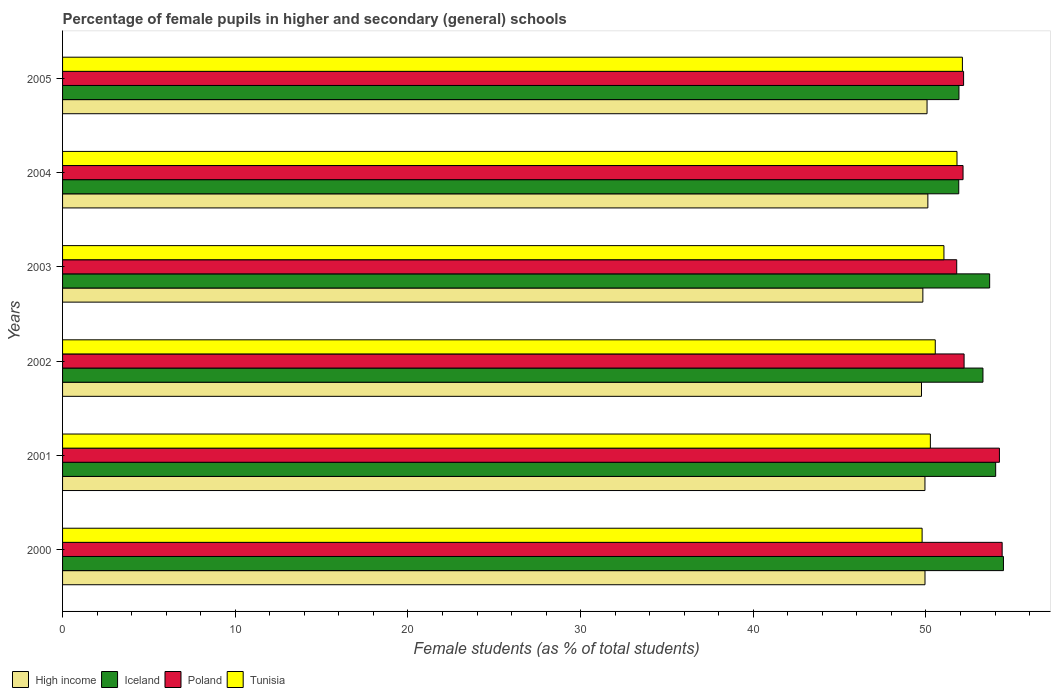How many different coloured bars are there?
Provide a succinct answer. 4. How many bars are there on the 2nd tick from the bottom?
Your answer should be very brief. 4. In how many cases, is the number of bars for a given year not equal to the number of legend labels?
Your answer should be compact. 0. What is the percentage of female pupils in higher and secondary schools in Iceland in 2005?
Your response must be concise. 51.91. Across all years, what is the maximum percentage of female pupils in higher and secondary schools in Iceland?
Keep it short and to the point. 54.49. Across all years, what is the minimum percentage of female pupils in higher and secondary schools in Iceland?
Your response must be concise. 51.9. What is the total percentage of female pupils in higher and secondary schools in High income in the graph?
Provide a succinct answer. 299.61. What is the difference between the percentage of female pupils in higher and secondary schools in Tunisia in 2001 and that in 2002?
Your answer should be compact. -0.28. What is the difference between the percentage of female pupils in higher and secondary schools in Poland in 2004 and the percentage of female pupils in higher and secondary schools in Iceland in 2003?
Keep it short and to the point. -1.54. What is the average percentage of female pupils in higher and secondary schools in Iceland per year?
Keep it short and to the point. 53.22. In the year 2005, what is the difference between the percentage of female pupils in higher and secondary schools in Iceland and percentage of female pupils in higher and secondary schools in High income?
Offer a very short reply. 1.85. What is the ratio of the percentage of female pupils in higher and secondary schools in Poland in 2002 to that in 2005?
Give a very brief answer. 1. Is the percentage of female pupils in higher and secondary schools in High income in 2004 less than that in 2005?
Give a very brief answer. No. What is the difference between the highest and the second highest percentage of female pupils in higher and secondary schools in High income?
Provide a succinct answer. 0.05. What is the difference between the highest and the lowest percentage of female pupils in higher and secondary schools in Tunisia?
Provide a short and direct response. 2.33. Is the sum of the percentage of female pupils in higher and secondary schools in Poland in 2000 and 2004 greater than the maximum percentage of female pupils in higher and secondary schools in High income across all years?
Offer a terse response. Yes. Is it the case that in every year, the sum of the percentage of female pupils in higher and secondary schools in Tunisia and percentage of female pupils in higher and secondary schools in Poland is greater than the sum of percentage of female pupils in higher and secondary schools in Iceland and percentage of female pupils in higher and secondary schools in High income?
Your answer should be compact. Yes. What does the 3rd bar from the top in 2000 represents?
Keep it short and to the point. Iceland. What does the 4th bar from the bottom in 2004 represents?
Make the answer very short. Tunisia. Are all the bars in the graph horizontal?
Your answer should be compact. Yes. What is the difference between two consecutive major ticks on the X-axis?
Give a very brief answer. 10. Are the values on the major ticks of X-axis written in scientific E-notation?
Provide a succinct answer. No. Does the graph contain grids?
Give a very brief answer. No. How many legend labels are there?
Provide a short and direct response. 4. How are the legend labels stacked?
Offer a very short reply. Horizontal. What is the title of the graph?
Make the answer very short. Percentage of female pupils in higher and secondary (general) schools. Does "Bangladesh" appear as one of the legend labels in the graph?
Ensure brevity in your answer.  No. What is the label or title of the X-axis?
Provide a short and direct response. Female students (as % of total students). What is the Female students (as % of total students) in High income in 2000?
Give a very brief answer. 49.94. What is the Female students (as % of total students) in Iceland in 2000?
Provide a short and direct response. 54.49. What is the Female students (as % of total students) of Poland in 2000?
Your answer should be very brief. 54.41. What is the Female students (as % of total students) of Tunisia in 2000?
Provide a short and direct response. 49.78. What is the Female students (as % of total students) in High income in 2001?
Offer a very short reply. 49.94. What is the Female students (as % of total students) in Iceland in 2001?
Provide a short and direct response. 54.04. What is the Female students (as % of total students) in Poland in 2001?
Give a very brief answer. 54.25. What is the Female students (as % of total students) in Tunisia in 2001?
Your answer should be compact. 50.25. What is the Female students (as % of total students) in High income in 2002?
Offer a terse response. 49.74. What is the Female students (as % of total students) of Iceland in 2002?
Your response must be concise. 53.3. What is the Female students (as % of total students) of Poland in 2002?
Your answer should be very brief. 52.21. What is the Female students (as % of total students) of Tunisia in 2002?
Your response must be concise. 50.54. What is the Female students (as % of total students) of High income in 2003?
Offer a very short reply. 49.82. What is the Female students (as % of total students) of Iceland in 2003?
Your response must be concise. 53.69. What is the Female students (as % of total students) in Poland in 2003?
Your answer should be very brief. 51.78. What is the Female students (as % of total students) in Tunisia in 2003?
Keep it short and to the point. 51.04. What is the Female students (as % of total students) of High income in 2004?
Provide a succinct answer. 50.11. What is the Female students (as % of total students) in Iceland in 2004?
Provide a succinct answer. 51.9. What is the Female students (as % of total students) of Poland in 2004?
Offer a terse response. 52.15. What is the Female students (as % of total students) of Tunisia in 2004?
Your answer should be compact. 51.8. What is the Female students (as % of total students) of High income in 2005?
Give a very brief answer. 50.06. What is the Female students (as % of total students) of Iceland in 2005?
Provide a short and direct response. 51.91. What is the Female students (as % of total students) of Poland in 2005?
Offer a very short reply. 52.18. What is the Female students (as % of total students) in Tunisia in 2005?
Offer a terse response. 52.11. Across all years, what is the maximum Female students (as % of total students) of High income?
Give a very brief answer. 50.11. Across all years, what is the maximum Female students (as % of total students) in Iceland?
Give a very brief answer. 54.49. Across all years, what is the maximum Female students (as % of total students) in Poland?
Your answer should be compact. 54.41. Across all years, what is the maximum Female students (as % of total students) in Tunisia?
Give a very brief answer. 52.11. Across all years, what is the minimum Female students (as % of total students) in High income?
Offer a terse response. 49.74. Across all years, what is the minimum Female students (as % of total students) in Iceland?
Offer a very short reply. 51.9. Across all years, what is the minimum Female students (as % of total students) in Poland?
Provide a short and direct response. 51.78. Across all years, what is the minimum Female students (as % of total students) of Tunisia?
Your response must be concise. 49.78. What is the total Female students (as % of total students) in High income in the graph?
Ensure brevity in your answer.  299.61. What is the total Female students (as % of total students) in Iceland in the graph?
Your answer should be very brief. 319.32. What is the total Female students (as % of total students) of Poland in the graph?
Provide a short and direct response. 316.98. What is the total Female students (as % of total students) in Tunisia in the graph?
Give a very brief answer. 305.51. What is the difference between the Female students (as % of total students) of High income in 2000 and that in 2001?
Offer a terse response. 0. What is the difference between the Female students (as % of total students) in Iceland in 2000 and that in 2001?
Offer a terse response. 0.45. What is the difference between the Female students (as % of total students) of Poland in 2000 and that in 2001?
Your response must be concise. 0.16. What is the difference between the Female students (as % of total students) in Tunisia in 2000 and that in 2001?
Provide a succinct answer. -0.48. What is the difference between the Female students (as % of total students) in High income in 2000 and that in 2002?
Provide a succinct answer. 0.2. What is the difference between the Female students (as % of total students) of Iceland in 2000 and that in 2002?
Keep it short and to the point. 1.19. What is the difference between the Female students (as % of total students) of Poland in 2000 and that in 2002?
Give a very brief answer. 2.2. What is the difference between the Female students (as % of total students) in Tunisia in 2000 and that in 2002?
Your response must be concise. -0.76. What is the difference between the Female students (as % of total students) in High income in 2000 and that in 2003?
Your answer should be compact. 0.12. What is the difference between the Female students (as % of total students) of Iceland in 2000 and that in 2003?
Provide a succinct answer. 0.8. What is the difference between the Female students (as % of total students) in Poland in 2000 and that in 2003?
Keep it short and to the point. 2.63. What is the difference between the Female students (as % of total students) of Tunisia in 2000 and that in 2003?
Your response must be concise. -1.26. What is the difference between the Female students (as % of total students) in High income in 2000 and that in 2004?
Offer a terse response. -0.17. What is the difference between the Female students (as % of total students) in Iceland in 2000 and that in 2004?
Your response must be concise. 2.59. What is the difference between the Female students (as % of total students) of Poland in 2000 and that in 2004?
Ensure brevity in your answer.  2.27. What is the difference between the Female students (as % of total students) in Tunisia in 2000 and that in 2004?
Your answer should be compact. -2.02. What is the difference between the Female students (as % of total students) in High income in 2000 and that in 2005?
Provide a short and direct response. -0.12. What is the difference between the Female students (as % of total students) of Iceland in 2000 and that in 2005?
Provide a succinct answer. 2.58. What is the difference between the Female students (as % of total students) of Poland in 2000 and that in 2005?
Give a very brief answer. 2.23. What is the difference between the Female students (as % of total students) of Tunisia in 2000 and that in 2005?
Your answer should be very brief. -2.33. What is the difference between the Female students (as % of total students) in High income in 2001 and that in 2002?
Your response must be concise. 0.2. What is the difference between the Female students (as % of total students) of Iceland in 2001 and that in 2002?
Keep it short and to the point. 0.74. What is the difference between the Female students (as % of total students) of Poland in 2001 and that in 2002?
Provide a succinct answer. 2.05. What is the difference between the Female students (as % of total students) in Tunisia in 2001 and that in 2002?
Offer a terse response. -0.28. What is the difference between the Female students (as % of total students) of High income in 2001 and that in 2003?
Your answer should be very brief. 0.12. What is the difference between the Female students (as % of total students) in Iceland in 2001 and that in 2003?
Provide a succinct answer. 0.35. What is the difference between the Female students (as % of total students) in Poland in 2001 and that in 2003?
Offer a very short reply. 2.47. What is the difference between the Female students (as % of total students) in Tunisia in 2001 and that in 2003?
Offer a very short reply. -0.79. What is the difference between the Female students (as % of total students) in High income in 2001 and that in 2004?
Give a very brief answer. -0.17. What is the difference between the Female students (as % of total students) in Iceland in 2001 and that in 2004?
Ensure brevity in your answer.  2.14. What is the difference between the Female students (as % of total students) of Poland in 2001 and that in 2004?
Provide a short and direct response. 2.11. What is the difference between the Female students (as % of total students) in Tunisia in 2001 and that in 2004?
Your response must be concise. -1.54. What is the difference between the Female students (as % of total students) of High income in 2001 and that in 2005?
Offer a very short reply. -0.12. What is the difference between the Female students (as % of total students) in Iceland in 2001 and that in 2005?
Provide a short and direct response. 2.13. What is the difference between the Female students (as % of total students) of Poland in 2001 and that in 2005?
Make the answer very short. 2.08. What is the difference between the Female students (as % of total students) in Tunisia in 2001 and that in 2005?
Provide a succinct answer. -1.86. What is the difference between the Female students (as % of total students) of High income in 2002 and that in 2003?
Your answer should be very brief. -0.08. What is the difference between the Female students (as % of total students) of Iceland in 2002 and that in 2003?
Your response must be concise. -0.39. What is the difference between the Female students (as % of total students) of Poland in 2002 and that in 2003?
Offer a very short reply. 0.43. What is the difference between the Female students (as % of total students) in Tunisia in 2002 and that in 2003?
Your answer should be very brief. -0.5. What is the difference between the Female students (as % of total students) of High income in 2002 and that in 2004?
Your response must be concise. -0.37. What is the difference between the Female students (as % of total students) of Iceland in 2002 and that in 2004?
Your answer should be compact. 1.4. What is the difference between the Female students (as % of total students) of Poland in 2002 and that in 2004?
Ensure brevity in your answer.  0.06. What is the difference between the Female students (as % of total students) in Tunisia in 2002 and that in 2004?
Offer a very short reply. -1.26. What is the difference between the Female students (as % of total students) in High income in 2002 and that in 2005?
Your answer should be very brief. -0.32. What is the difference between the Female students (as % of total students) in Iceland in 2002 and that in 2005?
Your answer should be compact. 1.39. What is the difference between the Female students (as % of total students) in Poland in 2002 and that in 2005?
Your response must be concise. 0.03. What is the difference between the Female students (as % of total students) in Tunisia in 2002 and that in 2005?
Offer a terse response. -1.57. What is the difference between the Female students (as % of total students) in High income in 2003 and that in 2004?
Provide a succinct answer. -0.29. What is the difference between the Female students (as % of total students) in Iceland in 2003 and that in 2004?
Your answer should be compact. 1.79. What is the difference between the Female students (as % of total students) of Poland in 2003 and that in 2004?
Ensure brevity in your answer.  -0.37. What is the difference between the Female students (as % of total students) in Tunisia in 2003 and that in 2004?
Offer a very short reply. -0.76. What is the difference between the Female students (as % of total students) in High income in 2003 and that in 2005?
Offer a terse response. -0.24. What is the difference between the Female students (as % of total students) in Iceland in 2003 and that in 2005?
Give a very brief answer. 1.78. What is the difference between the Female students (as % of total students) in Poland in 2003 and that in 2005?
Your response must be concise. -0.4. What is the difference between the Female students (as % of total students) in Tunisia in 2003 and that in 2005?
Ensure brevity in your answer.  -1.07. What is the difference between the Female students (as % of total students) of High income in 2004 and that in 2005?
Your answer should be very brief. 0.05. What is the difference between the Female students (as % of total students) of Iceland in 2004 and that in 2005?
Make the answer very short. -0.01. What is the difference between the Female students (as % of total students) in Poland in 2004 and that in 2005?
Offer a terse response. -0.03. What is the difference between the Female students (as % of total students) in Tunisia in 2004 and that in 2005?
Keep it short and to the point. -0.31. What is the difference between the Female students (as % of total students) of High income in 2000 and the Female students (as % of total students) of Iceland in 2001?
Provide a succinct answer. -4.09. What is the difference between the Female students (as % of total students) in High income in 2000 and the Female students (as % of total students) in Poland in 2001?
Provide a short and direct response. -4.31. What is the difference between the Female students (as % of total students) of High income in 2000 and the Female students (as % of total students) of Tunisia in 2001?
Offer a very short reply. -0.31. What is the difference between the Female students (as % of total students) of Iceland in 2000 and the Female students (as % of total students) of Poland in 2001?
Ensure brevity in your answer.  0.23. What is the difference between the Female students (as % of total students) in Iceland in 2000 and the Female students (as % of total students) in Tunisia in 2001?
Ensure brevity in your answer.  4.23. What is the difference between the Female students (as % of total students) of Poland in 2000 and the Female students (as % of total students) of Tunisia in 2001?
Keep it short and to the point. 4.16. What is the difference between the Female students (as % of total students) in High income in 2000 and the Female students (as % of total students) in Iceland in 2002?
Your answer should be compact. -3.36. What is the difference between the Female students (as % of total students) in High income in 2000 and the Female students (as % of total students) in Poland in 2002?
Your response must be concise. -2.26. What is the difference between the Female students (as % of total students) of High income in 2000 and the Female students (as % of total students) of Tunisia in 2002?
Your response must be concise. -0.59. What is the difference between the Female students (as % of total students) of Iceland in 2000 and the Female students (as % of total students) of Poland in 2002?
Offer a terse response. 2.28. What is the difference between the Female students (as % of total students) in Iceland in 2000 and the Female students (as % of total students) in Tunisia in 2002?
Give a very brief answer. 3.95. What is the difference between the Female students (as % of total students) of Poland in 2000 and the Female students (as % of total students) of Tunisia in 2002?
Make the answer very short. 3.87. What is the difference between the Female students (as % of total students) in High income in 2000 and the Female students (as % of total students) in Iceland in 2003?
Keep it short and to the point. -3.74. What is the difference between the Female students (as % of total students) in High income in 2000 and the Female students (as % of total students) in Poland in 2003?
Keep it short and to the point. -1.84. What is the difference between the Female students (as % of total students) of High income in 2000 and the Female students (as % of total students) of Tunisia in 2003?
Keep it short and to the point. -1.1. What is the difference between the Female students (as % of total students) of Iceland in 2000 and the Female students (as % of total students) of Poland in 2003?
Ensure brevity in your answer.  2.71. What is the difference between the Female students (as % of total students) in Iceland in 2000 and the Female students (as % of total students) in Tunisia in 2003?
Give a very brief answer. 3.45. What is the difference between the Female students (as % of total students) in Poland in 2000 and the Female students (as % of total students) in Tunisia in 2003?
Your answer should be compact. 3.37. What is the difference between the Female students (as % of total students) in High income in 2000 and the Female students (as % of total students) in Iceland in 2004?
Your response must be concise. -1.95. What is the difference between the Female students (as % of total students) of High income in 2000 and the Female students (as % of total students) of Poland in 2004?
Provide a short and direct response. -2.2. What is the difference between the Female students (as % of total students) of High income in 2000 and the Female students (as % of total students) of Tunisia in 2004?
Your response must be concise. -1.85. What is the difference between the Female students (as % of total students) of Iceland in 2000 and the Female students (as % of total students) of Poland in 2004?
Offer a very short reply. 2.34. What is the difference between the Female students (as % of total students) of Iceland in 2000 and the Female students (as % of total students) of Tunisia in 2004?
Give a very brief answer. 2.69. What is the difference between the Female students (as % of total students) of Poland in 2000 and the Female students (as % of total students) of Tunisia in 2004?
Your response must be concise. 2.62. What is the difference between the Female students (as % of total students) of High income in 2000 and the Female students (as % of total students) of Iceland in 2005?
Provide a succinct answer. -1.97. What is the difference between the Female students (as % of total students) in High income in 2000 and the Female students (as % of total students) in Poland in 2005?
Provide a succinct answer. -2.23. What is the difference between the Female students (as % of total students) in High income in 2000 and the Female students (as % of total students) in Tunisia in 2005?
Provide a succinct answer. -2.17. What is the difference between the Female students (as % of total students) in Iceland in 2000 and the Female students (as % of total students) in Poland in 2005?
Keep it short and to the point. 2.31. What is the difference between the Female students (as % of total students) of Iceland in 2000 and the Female students (as % of total students) of Tunisia in 2005?
Give a very brief answer. 2.38. What is the difference between the Female students (as % of total students) in Poland in 2000 and the Female students (as % of total students) in Tunisia in 2005?
Your answer should be compact. 2.3. What is the difference between the Female students (as % of total students) of High income in 2001 and the Female students (as % of total students) of Iceland in 2002?
Keep it short and to the point. -3.36. What is the difference between the Female students (as % of total students) in High income in 2001 and the Female students (as % of total students) in Poland in 2002?
Make the answer very short. -2.27. What is the difference between the Female students (as % of total students) in High income in 2001 and the Female students (as % of total students) in Tunisia in 2002?
Give a very brief answer. -0.6. What is the difference between the Female students (as % of total students) in Iceland in 2001 and the Female students (as % of total students) in Poland in 2002?
Keep it short and to the point. 1.83. What is the difference between the Female students (as % of total students) in Iceland in 2001 and the Female students (as % of total students) in Tunisia in 2002?
Make the answer very short. 3.5. What is the difference between the Female students (as % of total students) of Poland in 2001 and the Female students (as % of total students) of Tunisia in 2002?
Offer a terse response. 3.72. What is the difference between the Female students (as % of total students) of High income in 2001 and the Female students (as % of total students) of Iceland in 2003?
Ensure brevity in your answer.  -3.75. What is the difference between the Female students (as % of total students) in High income in 2001 and the Female students (as % of total students) in Poland in 2003?
Keep it short and to the point. -1.84. What is the difference between the Female students (as % of total students) of High income in 2001 and the Female students (as % of total students) of Tunisia in 2003?
Offer a terse response. -1.1. What is the difference between the Female students (as % of total students) of Iceland in 2001 and the Female students (as % of total students) of Poland in 2003?
Give a very brief answer. 2.26. What is the difference between the Female students (as % of total students) in Iceland in 2001 and the Female students (as % of total students) in Tunisia in 2003?
Provide a succinct answer. 3. What is the difference between the Female students (as % of total students) in Poland in 2001 and the Female students (as % of total students) in Tunisia in 2003?
Offer a terse response. 3.21. What is the difference between the Female students (as % of total students) in High income in 2001 and the Female students (as % of total students) in Iceland in 2004?
Your answer should be compact. -1.96. What is the difference between the Female students (as % of total students) of High income in 2001 and the Female students (as % of total students) of Poland in 2004?
Ensure brevity in your answer.  -2.21. What is the difference between the Female students (as % of total students) in High income in 2001 and the Female students (as % of total students) in Tunisia in 2004?
Ensure brevity in your answer.  -1.86. What is the difference between the Female students (as % of total students) in Iceland in 2001 and the Female students (as % of total students) in Poland in 2004?
Your answer should be very brief. 1.89. What is the difference between the Female students (as % of total students) of Iceland in 2001 and the Female students (as % of total students) of Tunisia in 2004?
Make the answer very short. 2.24. What is the difference between the Female students (as % of total students) in Poland in 2001 and the Female students (as % of total students) in Tunisia in 2004?
Give a very brief answer. 2.46. What is the difference between the Female students (as % of total students) of High income in 2001 and the Female students (as % of total students) of Iceland in 2005?
Your answer should be compact. -1.97. What is the difference between the Female students (as % of total students) in High income in 2001 and the Female students (as % of total students) in Poland in 2005?
Offer a terse response. -2.24. What is the difference between the Female students (as % of total students) in High income in 2001 and the Female students (as % of total students) in Tunisia in 2005?
Give a very brief answer. -2.17. What is the difference between the Female students (as % of total students) in Iceland in 2001 and the Female students (as % of total students) in Poland in 2005?
Your answer should be compact. 1.86. What is the difference between the Female students (as % of total students) of Iceland in 2001 and the Female students (as % of total students) of Tunisia in 2005?
Provide a succinct answer. 1.93. What is the difference between the Female students (as % of total students) in Poland in 2001 and the Female students (as % of total students) in Tunisia in 2005?
Give a very brief answer. 2.14. What is the difference between the Female students (as % of total students) in High income in 2002 and the Female students (as % of total students) in Iceland in 2003?
Your answer should be compact. -3.95. What is the difference between the Female students (as % of total students) in High income in 2002 and the Female students (as % of total students) in Poland in 2003?
Provide a short and direct response. -2.04. What is the difference between the Female students (as % of total students) of High income in 2002 and the Female students (as % of total students) of Tunisia in 2003?
Your answer should be compact. -1.3. What is the difference between the Female students (as % of total students) of Iceland in 2002 and the Female students (as % of total students) of Poland in 2003?
Make the answer very short. 1.52. What is the difference between the Female students (as % of total students) in Iceland in 2002 and the Female students (as % of total students) in Tunisia in 2003?
Offer a very short reply. 2.26. What is the difference between the Female students (as % of total students) in Poland in 2002 and the Female students (as % of total students) in Tunisia in 2003?
Your response must be concise. 1.17. What is the difference between the Female students (as % of total students) in High income in 2002 and the Female students (as % of total students) in Iceland in 2004?
Give a very brief answer. -2.16. What is the difference between the Female students (as % of total students) in High income in 2002 and the Female students (as % of total students) in Poland in 2004?
Your answer should be very brief. -2.41. What is the difference between the Female students (as % of total students) of High income in 2002 and the Female students (as % of total students) of Tunisia in 2004?
Offer a very short reply. -2.06. What is the difference between the Female students (as % of total students) of Iceland in 2002 and the Female students (as % of total students) of Poland in 2004?
Keep it short and to the point. 1.15. What is the difference between the Female students (as % of total students) of Iceland in 2002 and the Female students (as % of total students) of Tunisia in 2004?
Make the answer very short. 1.5. What is the difference between the Female students (as % of total students) of Poland in 2002 and the Female students (as % of total students) of Tunisia in 2004?
Ensure brevity in your answer.  0.41. What is the difference between the Female students (as % of total students) in High income in 2002 and the Female students (as % of total students) in Iceland in 2005?
Your answer should be very brief. -2.17. What is the difference between the Female students (as % of total students) of High income in 2002 and the Female students (as % of total students) of Poland in 2005?
Ensure brevity in your answer.  -2.44. What is the difference between the Female students (as % of total students) of High income in 2002 and the Female students (as % of total students) of Tunisia in 2005?
Provide a short and direct response. -2.37. What is the difference between the Female students (as % of total students) in Iceland in 2002 and the Female students (as % of total students) in Poland in 2005?
Make the answer very short. 1.12. What is the difference between the Female students (as % of total students) of Iceland in 2002 and the Female students (as % of total students) of Tunisia in 2005?
Provide a succinct answer. 1.19. What is the difference between the Female students (as % of total students) of Poland in 2002 and the Female students (as % of total students) of Tunisia in 2005?
Provide a succinct answer. 0.1. What is the difference between the Female students (as % of total students) in High income in 2003 and the Female students (as % of total students) in Iceland in 2004?
Your answer should be compact. -2.08. What is the difference between the Female students (as % of total students) of High income in 2003 and the Female students (as % of total students) of Poland in 2004?
Keep it short and to the point. -2.33. What is the difference between the Female students (as % of total students) of High income in 2003 and the Female students (as % of total students) of Tunisia in 2004?
Offer a terse response. -1.98. What is the difference between the Female students (as % of total students) of Iceland in 2003 and the Female students (as % of total students) of Poland in 2004?
Your answer should be compact. 1.54. What is the difference between the Female students (as % of total students) of Iceland in 2003 and the Female students (as % of total students) of Tunisia in 2004?
Your answer should be compact. 1.89. What is the difference between the Female students (as % of total students) of Poland in 2003 and the Female students (as % of total students) of Tunisia in 2004?
Keep it short and to the point. -0.02. What is the difference between the Female students (as % of total students) in High income in 2003 and the Female students (as % of total students) in Iceland in 2005?
Offer a terse response. -2.09. What is the difference between the Female students (as % of total students) of High income in 2003 and the Female students (as % of total students) of Poland in 2005?
Offer a very short reply. -2.36. What is the difference between the Female students (as % of total students) of High income in 2003 and the Female students (as % of total students) of Tunisia in 2005?
Give a very brief answer. -2.29. What is the difference between the Female students (as % of total students) in Iceland in 2003 and the Female students (as % of total students) in Poland in 2005?
Ensure brevity in your answer.  1.51. What is the difference between the Female students (as % of total students) of Iceland in 2003 and the Female students (as % of total students) of Tunisia in 2005?
Keep it short and to the point. 1.58. What is the difference between the Female students (as % of total students) of Poland in 2003 and the Female students (as % of total students) of Tunisia in 2005?
Ensure brevity in your answer.  -0.33. What is the difference between the Female students (as % of total students) in High income in 2004 and the Female students (as % of total students) in Iceland in 2005?
Provide a succinct answer. -1.8. What is the difference between the Female students (as % of total students) in High income in 2004 and the Female students (as % of total students) in Poland in 2005?
Make the answer very short. -2.07. What is the difference between the Female students (as % of total students) of High income in 2004 and the Female students (as % of total students) of Tunisia in 2005?
Ensure brevity in your answer.  -2. What is the difference between the Female students (as % of total students) in Iceland in 2004 and the Female students (as % of total students) in Poland in 2005?
Keep it short and to the point. -0.28. What is the difference between the Female students (as % of total students) in Iceland in 2004 and the Female students (as % of total students) in Tunisia in 2005?
Your answer should be very brief. -0.21. What is the difference between the Female students (as % of total students) in Poland in 2004 and the Female students (as % of total students) in Tunisia in 2005?
Your response must be concise. 0.04. What is the average Female students (as % of total students) of High income per year?
Give a very brief answer. 49.94. What is the average Female students (as % of total students) in Iceland per year?
Ensure brevity in your answer.  53.22. What is the average Female students (as % of total students) in Poland per year?
Provide a succinct answer. 52.83. What is the average Female students (as % of total students) in Tunisia per year?
Provide a short and direct response. 50.92. In the year 2000, what is the difference between the Female students (as % of total students) of High income and Female students (as % of total students) of Iceland?
Provide a succinct answer. -4.54. In the year 2000, what is the difference between the Female students (as % of total students) in High income and Female students (as % of total students) in Poland?
Make the answer very short. -4.47. In the year 2000, what is the difference between the Female students (as % of total students) of High income and Female students (as % of total students) of Tunisia?
Provide a succinct answer. 0.17. In the year 2000, what is the difference between the Female students (as % of total students) of Iceland and Female students (as % of total students) of Poland?
Your answer should be very brief. 0.07. In the year 2000, what is the difference between the Female students (as % of total students) in Iceland and Female students (as % of total students) in Tunisia?
Give a very brief answer. 4.71. In the year 2000, what is the difference between the Female students (as % of total students) in Poland and Female students (as % of total students) in Tunisia?
Offer a very short reply. 4.64. In the year 2001, what is the difference between the Female students (as % of total students) in High income and Female students (as % of total students) in Iceland?
Offer a very short reply. -4.1. In the year 2001, what is the difference between the Female students (as % of total students) in High income and Female students (as % of total students) in Poland?
Give a very brief answer. -4.31. In the year 2001, what is the difference between the Female students (as % of total students) in High income and Female students (as % of total students) in Tunisia?
Your response must be concise. -0.31. In the year 2001, what is the difference between the Female students (as % of total students) in Iceland and Female students (as % of total students) in Poland?
Your answer should be compact. -0.22. In the year 2001, what is the difference between the Female students (as % of total students) in Iceland and Female students (as % of total students) in Tunisia?
Offer a terse response. 3.78. In the year 2001, what is the difference between the Female students (as % of total students) of Poland and Female students (as % of total students) of Tunisia?
Your answer should be compact. 4. In the year 2002, what is the difference between the Female students (as % of total students) of High income and Female students (as % of total students) of Iceland?
Ensure brevity in your answer.  -3.56. In the year 2002, what is the difference between the Female students (as % of total students) in High income and Female students (as % of total students) in Poland?
Provide a succinct answer. -2.47. In the year 2002, what is the difference between the Female students (as % of total students) of High income and Female students (as % of total students) of Tunisia?
Provide a succinct answer. -0.8. In the year 2002, what is the difference between the Female students (as % of total students) of Iceland and Female students (as % of total students) of Poland?
Provide a succinct answer. 1.09. In the year 2002, what is the difference between the Female students (as % of total students) in Iceland and Female students (as % of total students) in Tunisia?
Provide a short and direct response. 2.76. In the year 2002, what is the difference between the Female students (as % of total students) of Poland and Female students (as % of total students) of Tunisia?
Your answer should be compact. 1.67. In the year 2003, what is the difference between the Female students (as % of total students) in High income and Female students (as % of total students) in Iceland?
Ensure brevity in your answer.  -3.87. In the year 2003, what is the difference between the Female students (as % of total students) of High income and Female students (as % of total students) of Poland?
Ensure brevity in your answer.  -1.96. In the year 2003, what is the difference between the Female students (as % of total students) of High income and Female students (as % of total students) of Tunisia?
Provide a succinct answer. -1.22. In the year 2003, what is the difference between the Female students (as % of total students) in Iceland and Female students (as % of total students) in Poland?
Provide a succinct answer. 1.91. In the year 2003, what is the difference between the Female students (as % of total students) in Iceland and Female students (as % of total students) in Tunisia?
Your answer should be compact. 2.65. In the year 2003, what is the difference between the Female students (as % of total students) of Poland and Female students (as % of total students) of Tunisia?
Your answer should be compact. 0.74. In the year 2004, what is the difference between the Female students (as % of total students) in High income and Female students (as % of total students) in Iceland?
Your answer should be compact. -1.79. In the year 2004, what is the difference between the Female students (as % of total students) in High income and Female students (as % of total students) in Poland?
Your answer should be compact. -2.04. In the year 2004, what is the difference between the Female students (as % of total students) of High income and Female students (as % of total students) of Tunisia?
Make the answer very short. -1.69. In the year 2004, what is the difference between the Female students (as % of total students) in Iceland and Female students (as % of total students) in Poland?
Ensure brevity in your answer.  -0.25. In the year 2004, what is the difference between the Female students (as % of total students) of Iceland and Female students (as % of total students) of Tunisia?
Your answer should be very brief. 0.1. In the year 2004, what is the difference between the Female students (as % of total students) of Poland and Female students (as % of total students) of Tunisia?
Ensure brevity in your answer.  0.35. In the year 2005, what is the difference between the Female students (as % of total students) of High income and Female students (as % of total students) of Iceland?
Offer a very short reply. -1.85. In the year 2005, what is the difference between the Female students (as % of total students) in High income and Female students (as % of total students) in Poland?
Provide a succinct answer. -2.12. In the year 2005, what is the difference between the Female students (as % of total students) in High income and Female students (as % of total students) in Tunisia?
Ensure brevity in your answer.  -2.05. In the year 2005, what is the difference between the Female students (as % of total students) in Iceland and Female students (as % of total students) in Poland?
Make the answer very short. -0.27. In the year 2005, what is the difference between the Female students (as % of total students) of Iceland and Female students (as % of total students) of Tunisia?
Provide a short and direct response. -0.2. In the year 2005, what is the difference between the Female students (as % of total students) in Poland and Female students (as % of total students) in Tunisia?
Offer a terse response. 0.07. What is the ratio of the Female students (as % of total students) in Iceland in 2000 to that in 2001?
Your answer should be very brief. 1.01. What is the ratio of the Female students (as % of total students) in Tunisia in 2000 to that in 2001?
Give a very brief answer. 0.99. What is the ratio of the Female students (as % of total students) of High income in 2000 to that in 2002?
Your response must be concise. 1. What is the ratio of the Female students (as % of total students) in Iceland in 2000 to that in 2002?
Offer a terse response. 1.02. What is the ratio of the Female students (as % of total students) of Poland in 2000 to that in 2002?
Your answer should be very brief. 1.04. What is the ratio of the Female students (as % of total students) of Tunisia in 2000 to that in 2002?
Offer a very short reply. 0.98. What is the ratio of the Female students (as % of total students) in High income in 2000 to that in 2003?
Your answer should be compact. 1. What is the ratio of the Female students (as % of total students) in Iceland in 2000 to that in 2003?
Your answer should be compact. 1.01. What is the ratio of the Female students (as % of total students) of Poland in 2000 to that in 2003?
Offer a very short reply. 1.05. What is the ratio of the Female students (as % of total students) of Tunisia in 2000 to that in 2003?
Ensure brevity in your answer.  0.98. What is the ratio of the Female students (as % of total students) in High income in 2000 to that in 2004?
Provide a short and direct response. 1. What is the ratio of the Female students (as % of total students) in Iceland in 2000 to that in 2004?
Ensure brevity in your answer.  1.05. What is the ratio of the Female students (as % of total students) of Poland in 2000 to that in 2004?
Provide a succinct answer. 1.04. What is the ratio of the Female students (as % of total students) in Tunisia in 2000 to that in 2004?
Provide a short and direct response. 0.96. What is the ratio of the Female students (as % of total students) in Iceland in 2000 to that in 2005?
Provide a succinct answer. 1.05. What is the ratio of the Female students (as % of total students) in Poland in 2000 to that in 2005?
Ensure brevity in your answer.  1.04. What is the ratio of the Female students (as % of total students) in Tunisia in 2000 to that in 2005?
Make the answer very short. 0.96. What is the ratio of the Female students (as % of total students) of High income in 2001 to that in 2002?
Ensure brevity in your answer.  1. What is the ratio of the Female students (as % of total students) in Iceland in 2001 to that in 2002?
Offer a terse response. 1.01. What is the ratio of the Female students (as % of total students) in Poland in 2001 to that in 2002?
Your answer should be compact. 1.04. What is the ratio of the Female students (as % of total students) of High income in 2001 to that in 2003?
Provide a succinct answer. 1. What is the ratio of the Female students (as % of total students) in Poland in 2001 to that in 2003?
Offer a terse response. 1.05. What is the ratio of the Female students (as % of total students) in Tunisia in 2001 to that in 2003?
Your response must be concise. 0.98. What is the ratio of the Female students (as % of total students) in High income in 2001 to that in 2004?
Provide a succinct answer. 1. What is the ratio of the Female students (as % of total students) in Iceland in 2001 to that in 2004?
Your response must be concise. 1.04. What is the ratio of the Female students (as % of total students) in Poland in 2001 to that in 2004?
Make the answer very short. 1.04. What is the ratio of the Female students (as % of total students) of Tunisia in 2001 to that in 2004?
Keep it short and to the point. 0.97. What is the ratio of the Female students (as % of total students) in High income in 2001 to that in 2005?
Provide a short and direct response. 1. What is the ratio of the Female students (as % of total students) in Iceland in 2001 to that in 2005?
Give a very brief answer. 1.04. What is the ratio of the Female students (as % of total students) of Poland in 2001 to that in 2005?
Offer a very short reply. 1.04. What is the ratio of the Female students (as % of total students) of Tunisia in 2001 to that in 2005?
Your answer should be compact. 0.96. What is the ratio of the Female students (as % of total students) in High income in 2002 to that in 2003?
Offer a terse response. 1. What is the ratio of the Female students (as % of total students) of Poland in 2002 to that in 2003?
Ensure brevity in your answer.  1.01. What is the ratio of the Female students (as % of total students) in Tunisia in 2002 to that in 2003?
Provide a succinct answer. 0.99. What is the ratio of the Female students (as % of total students) of Poland in 2002 to that in 2004?
Your response must be concise. 1. What is the ratio of the Female students (as % of total students) in Tunisia in 2002 to that in 2004?
Ensure brevity in your answer.  0.98. What is the ratio of the Female students (as % of total students) of High income in 2002 to that in 2005?
Your response must be concise. 0.99. What is the ratio of the Female students (as % of total students) of Iceland in 2002 to that in 2005?
Provide a short and direct response. 1.03. What is the ratio of the Female students (as % of total students) in Poland in 2002 to that in 2005?
Your response must be concise. 1. What is the ratio of the Female students (as % of total students) in Tunisia in 2002 to that in 2005?
Ensure brevity in your answer.  0.97. What is the ratio of the Female students (as % of total students) in High income in 2003 to that in 2004?
Your answer should be very brief. 0.99. What is the ratio of the Female students (as % of total students) in Iceland in 2003 to that in 2004?
Provide a short and direct response. 1.03. What is the ratio of the Female students (as % of total students) of Tunisia in 2003 to that in 2004?
Your response must be concise. 0.99. What is the ratio of the Female students (as % of total students) of Iceland in 2003 to that in 2005?
Offer a terse response. 1.03. What is the ratio of the Female students (as % of total students) of Tunisia in 2003 to that in 2005?
Keep it short and to the point. 0.98. What is the ratio of the Female students (as % of total students) in Tunisia in 2004 to that in 2005?
Offer a very short reply. 0.99. What is the difference between the highest and the second highest Female students (as % of total students) of High income?
Your answer should be very brief. 0.05. What is the difference between the highest and the second highest Female students (as % of total students) in Iceland?
Your answer should be very brief. 0.45. What is the difference between the highest and the second highest Female students (as % of total students) in Poland?
Provide a short and direct response. 0.16. What is the difference between the highest and the second highest Female students (as % of total students) of Tunisia?
Give a very brief answer. 0.31. What is the difference between the highest and the lowest Female students (as % of total students) of High income?
Offer a terse response. 0.37. What is the difference between the highest and the lowest Female students (as % of total students) of Iceland?
Provide a succinct answer. 2.59. What is the difference between the highest and the lowest Female students (as % of total students) of Poland?
Provide a short and direct response. 2.63. What is the difference between the highest and the lowest Female students (as % of total students) of Tunisia?
Provide a succinct answer. 2.33. 